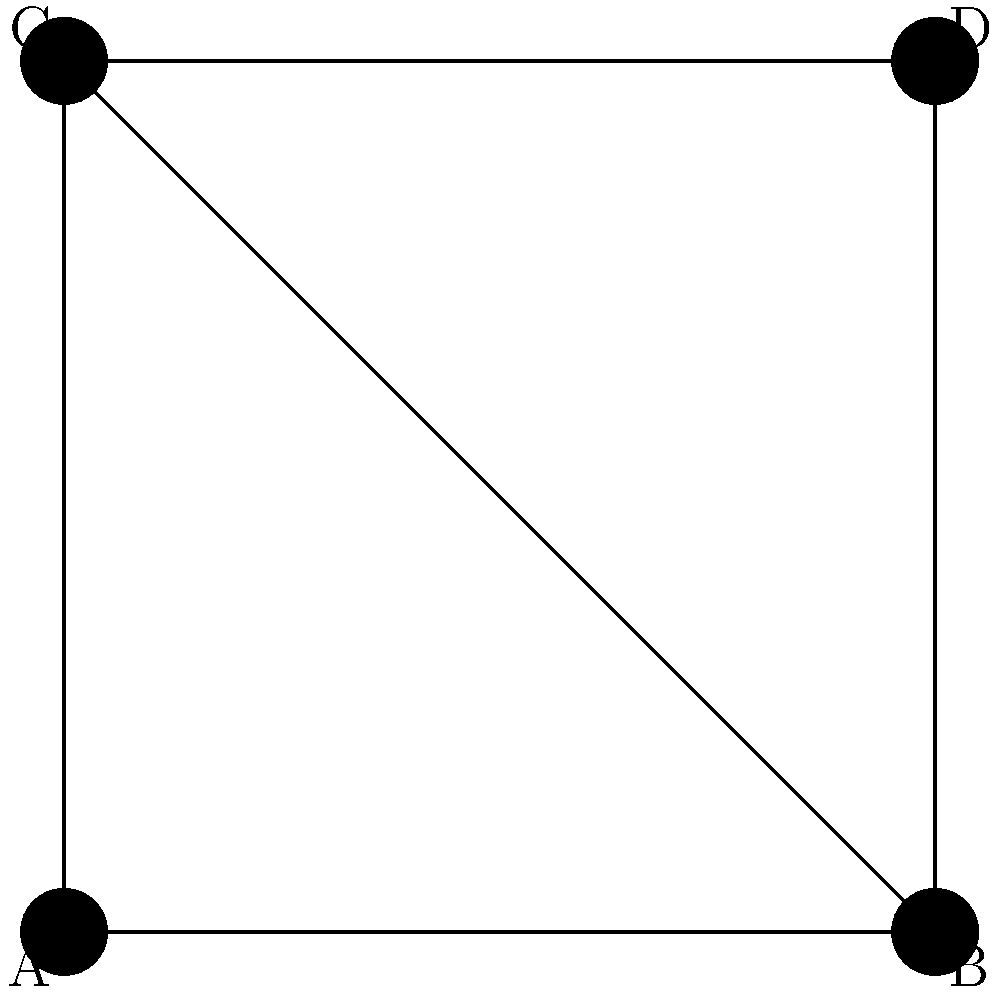During your commute, you're listening to an audiobook about network topologies. The narrator describes a network where each node is connected to every other node. Which topology type does the diagram above NOT represent, and how would you modify it to match the described topology? To answer this question, let's follow these steps:

1. Identify the topology in the given diagram:
   - The diagram shows 4 nodes (A, B, C, D) connected in a square shape with an additional diagonal connection (B-C).
   - This resembles a partial mesh topology, but not a full mesh.

2. Recall the description from the audiobook:
   - Each node is connected to every other node.
   - This description matches a full mesh topology.

3. Compare the diagram to a full mesh topology:
   - In a full mesh, there should be $\frac{n(n-1)}{2}$ connections, where $n$ is the number of nodes.
   - For 4 nodes, we should have $\frac{4(4-1)}{2} = 6$ connections.
   - The current diagram only has 5 connections.

4. Identify the missing connection:
   - The link between nodes A and D is missing.

5. Modification needed:
   - To transform this into a full mesh topology, we need to add a connection between nodes A and D.

Therefore, the diagram does not represent a full mesh topology, which is the type described in the audiobook. To modify it, we need to add one more connection between nodes A and D.
Answer: Full mesh topology; add connection between A and D 